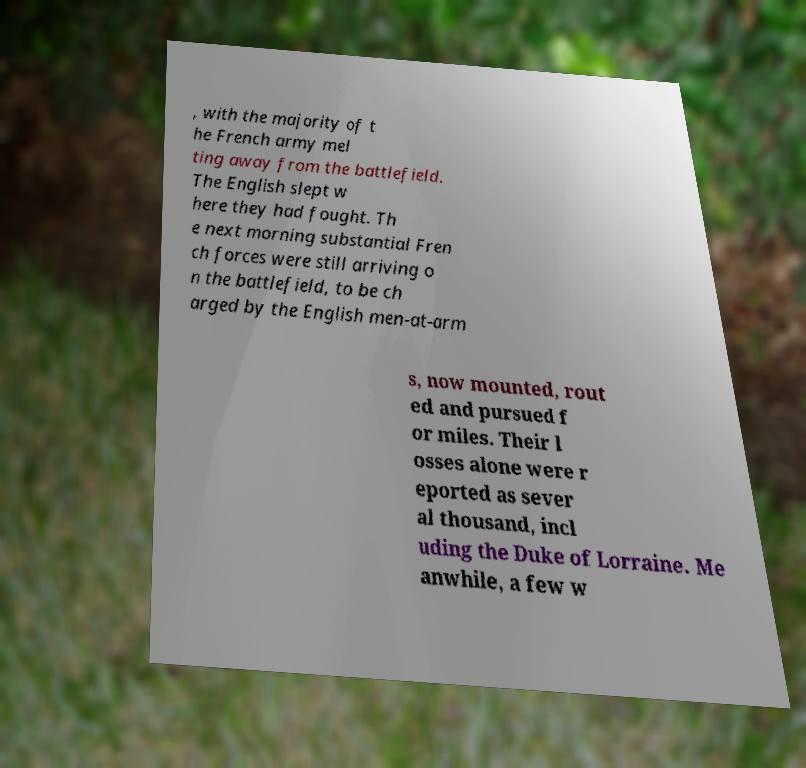Could you extract and type out the text from this image? , with the majority of t he French army mel ting away from the battlefield. The English slept w here they had fought. Th e next morning substantial Fren ch forces were still arriving o n the battlefield, to be ch arged by the English men-at-arm s, now mounted, rout ed and pursued f or miles. Their l osses alone were r eported as sever al thousand, incl uding the Duke of Lorraine. Me anwhile, a few w 